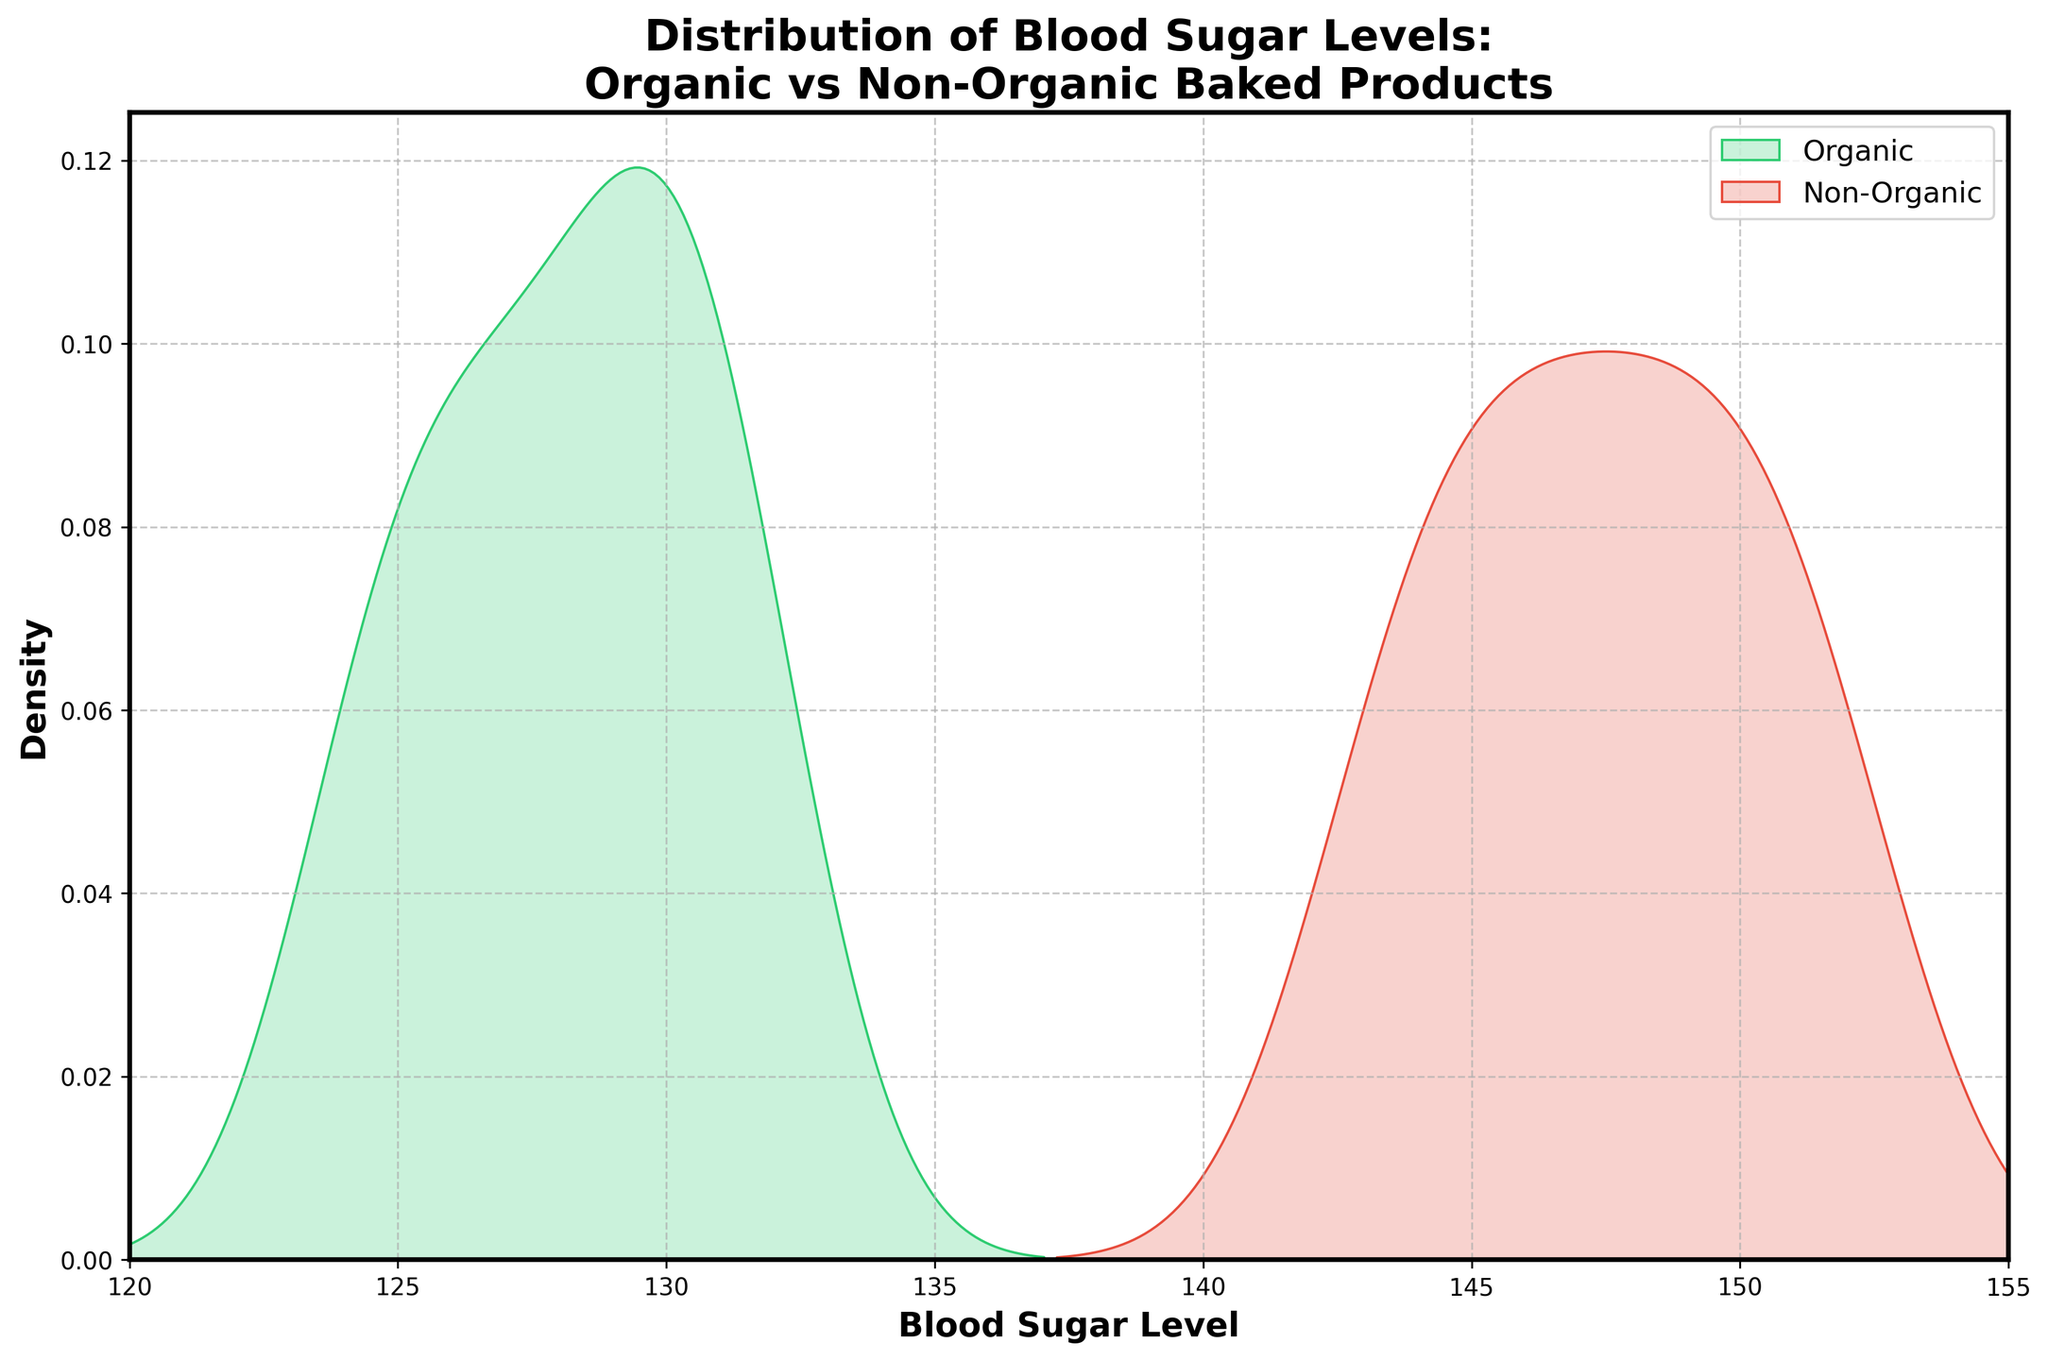What is the title of the figure? The title can be found at the top of the figure and informs about the content displayed.
Answer: Distribution of Blood Sugar Levels: Organic vs Non-Organic Baked Products What are the x-axis and y-axis labeled? The x-axis and y-axis labels provide information about what each axis represents. The x-axis shows 'Blood Sugar Level' while the y-axis shows 'Density'.
Answer: Blood Sugar Level (x-axis), Density (y-axis) Which color represents Organic baked products? The color for Organic baked products is visible in the legend on the right side of the figure.
Answer: Green Which group shows higher density around 145-150 blood sugar level? Check the density lines on the graph; the Non-Organic line will peak higher in this range.
Answer: Non-Organic Which group has a lower average blood sugar level? Look at the peak of the density curves. The Organic group peaks at a lower blood sugar level compared to Non-Organic.
Answer: Organic What is the range of blood sugar levels on the x-axis? The number of intervals between ticks and their values indicate the range. The axis spans from 120 to 155.
Answer: 120 to 155 How does the spread of the Organic group's blood sugar levels compare to the Non-Organic group? Check the width of the density curves. If the Organic curve is more narrow and concentrated, it's less spread out than the Non-Organic curve.
Answer: The Organic group is less spread out At approximately what blood sugar level peak do Organic baked products have? Observe the highest point of the density curve for the Organic group.
Answer: Around 130 What general conclusion can be made about the blood sugar levels after consuming Organic vs. Non-Organic baked products? Compare the peak and the spread of both density curves. The Organic group generally has lower blood sugar levels and less variability.
Answer: Organic leads to lower and more stable blood sugar levels How many major peaks are observed in the density plot, and at what levels? Count the noticeable peaks in each density curve and note their approximate blood sugar levels.
Answer: Two major peaks: organic around 130 and non-organic around 148 